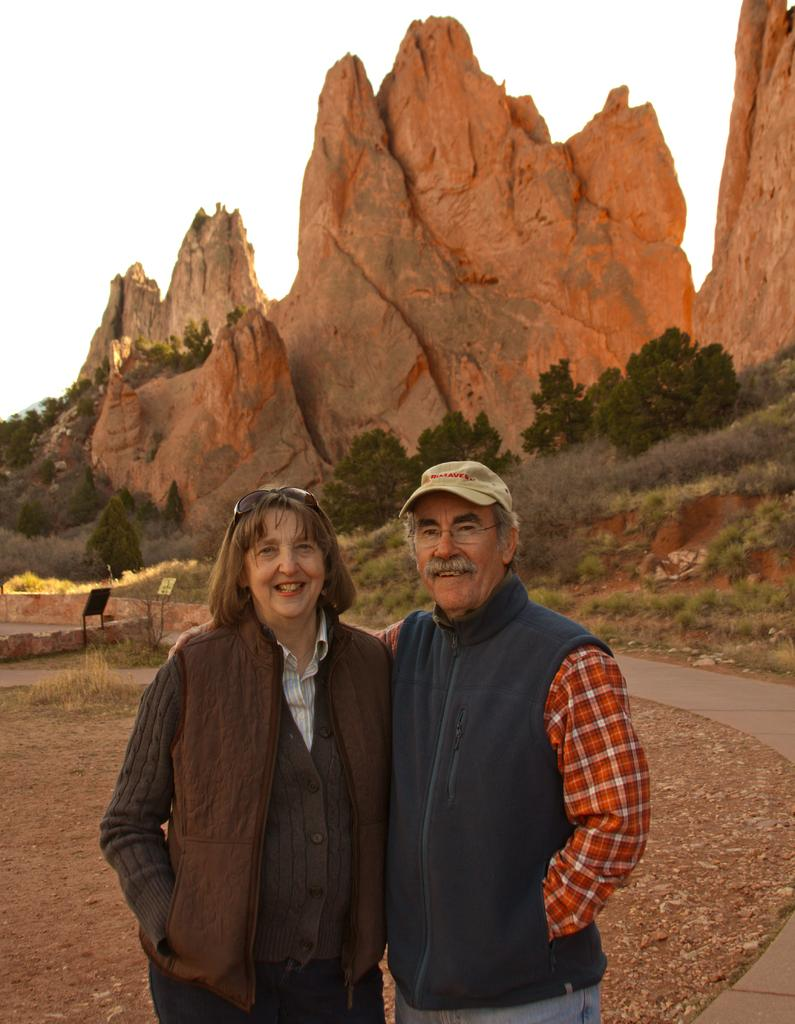How many people are present in the image? There are two people, a man and a woman, present in the image. Where are the man and woman located in the image? The man and woman are in the middle of the image. What can be seen in the background of the image? There are trees and hills in the background of the image. What is visible at the top of the image? The sky is visible at the top of the image. What type of lettuce is being used as a hat by the man in the image? There is no lettuce present in the image, and the man is not wearing a hat. 